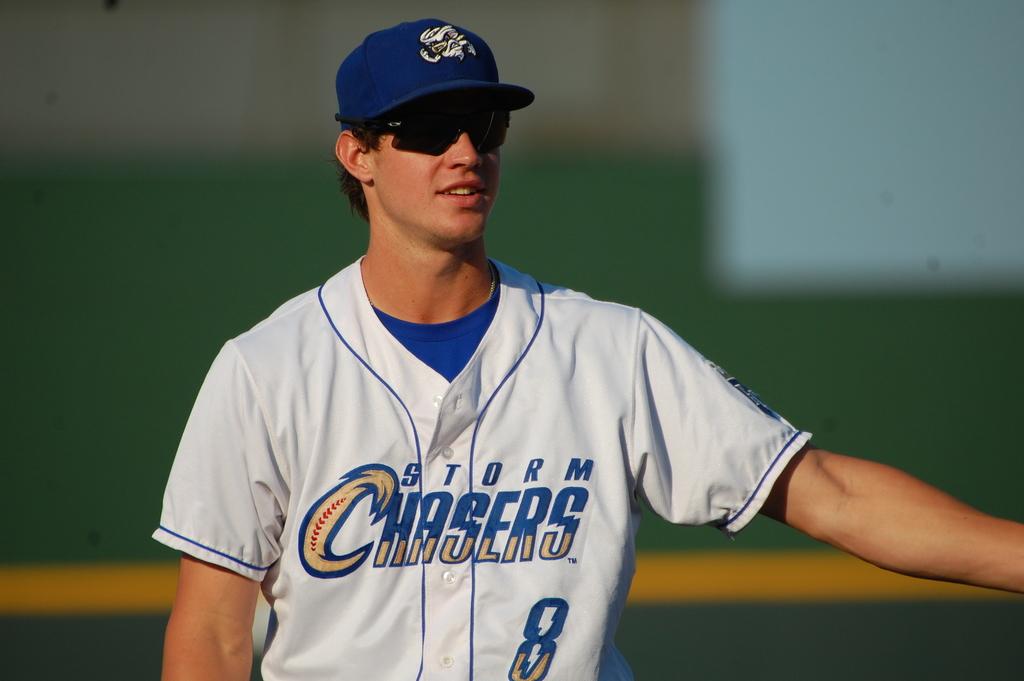What team does the man play for?
Ensure brevity in your answer.  Storm chasers. What number is the player wearing?
Give a very brief answer. 8. 